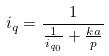<formula> <loc_0><loc_0><loc_500><loc_500>i _ { q } = \frac { 1 } { \frac { 1 } { i _ { q _ { 0 } } } + \frac { k a } { p } }</formula> 